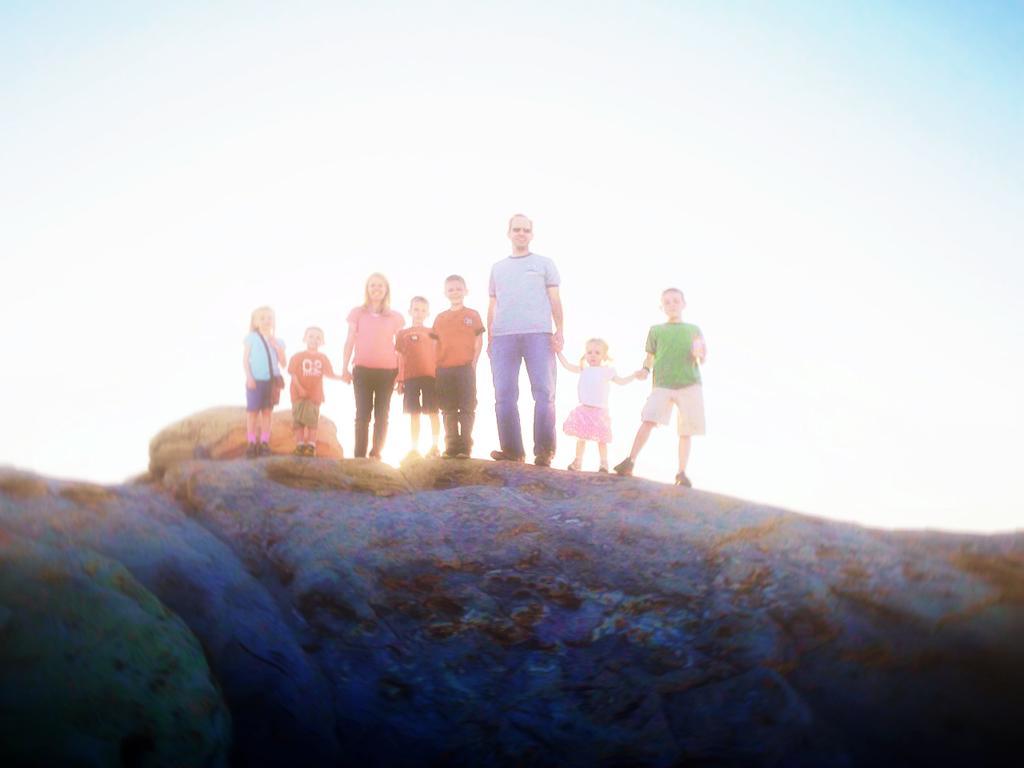How would you summarize this image in a sentence or two? In this image there are rocks, on that rocks people are standing, in the background there is the sky. 